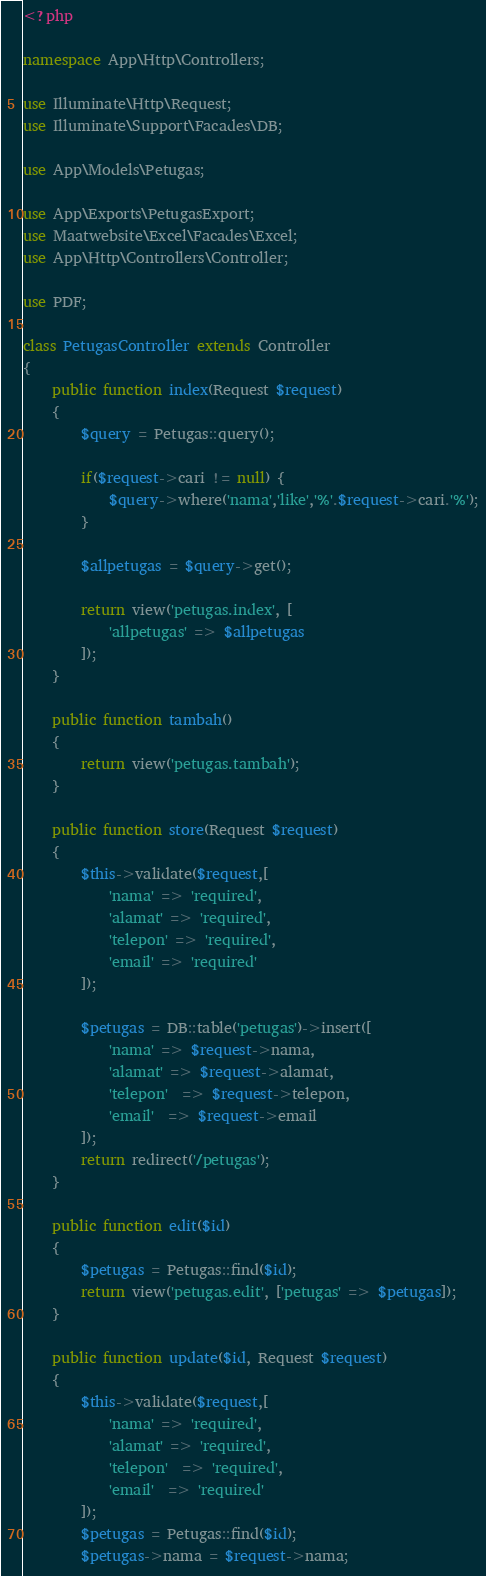Convert code to text. <code><loc_0><loc_0><loc_500><loc_500><_PHP_><?php

namespace App\Http\Controllers;

use Illuminate\Http\Request;
use Illuminate\Support\Facades\DB;

use App\Models\Petugas;

use App\Exports\PetugasExport;
use Maatwebsite\Excel\Facades\Excel;
use App\Http\Controllers\Controller;

use PDF;

class PetugasController extends Controller
{
    public function index(Request $request)
    {
        $query = Petugas::query();

        if($request->cari != null) {
            $query->where('nama','like','%'.$request->cari.'%');
        }

        $allpetugas = $query->get();

        return view('petugas.index', [
            'allpetugas' => $allpetugas
        ]);
    }

    public function tambah()
    {
    	return view('petugas.tambah');
    }

    public function store(Request $request)
    {
    	$this->validate($request,[
    		'nama' => 'required',
    		'alamat' => 'required',
    		'telepon' => 'required',
    		'email' => 'required'
    	]);

    	$petugas = DB::table('petugas')->insert([
    		'nama' => $request->nama,
    		'alamat' => $request->alamat,
    		'telepon'  => $request->telepon,
    		'email'  => $request->email
    	]);
    	return redirect('/petugas');
    }

    public function edit($id)
    {
    	$petugas = Petugas::find($id);
    	return view('petugas.edit', ['petugas' => $petugas]);
    }

    public function update($id, Request $request)
    {
     	$this->validate($request,[
     		'nama' => 'required',
     		'alamat' => 'required',
     		'telepon'  => 'required',
     		'email'  => 'required'
     	]);
     	$petugas = Petugas::find($id);
     	$petugas->nama = $request->nama;</code> 